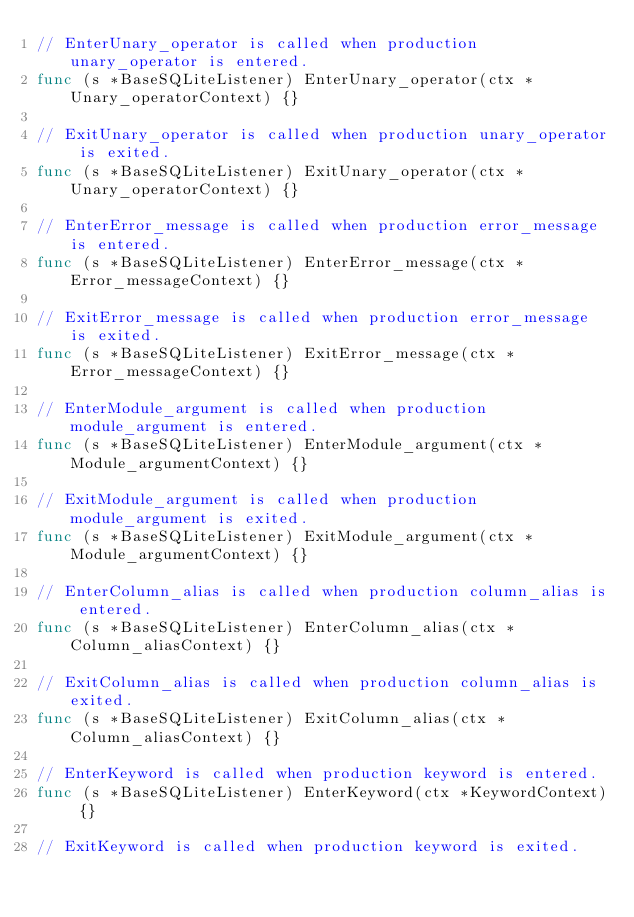<code> <loc_0><loc_0><loc_500><loc_500><_Go_>// EnterUnary_operator is called when production unary_operator is entered.
func (s *BaseSQLiteListener) EnterUnary_operator(ctx *Unary_operatorContext) {}

// ExitUnary_operator is called when production unary_operator is exited.
func (s *BaseSQLiteListener) ExitUnary_operator(ctx *Unary_operatorContext) {}

// EnterError_message is called when production error_message is entered.
func (s *BaseSQLiteListener) EnterError_message(ctx *Error_messageContext) {}

// ExitError_message is called when production error_message is exited.
func (s *BaseSQLiteListener) ExitError_message(ctx *Error_messageContext) {}

// EnterModule_argument is called when production module_argument is entered.
func (s *BaseSQLiteListener) EnterModule_argument(ctx *Module_argumentContext) {}

// ExitModule_argument is called when production module_argument is exited.
func (s *BaseSQLiteListener) ExitModule_argument(ctx *Module_argumentContext) {}

// EnterColumn_alias is called when production column_alias is entered.
func (s *BaseSQLiteListener) EnterColumn_alias(ctx *Column_aliasContext) {}

// ExitColumn_alias is called when production column_alias is exited.
func (s *BaseSQLiteListener) ExitColumn_alias(ctx *Column_aliasContext) {}

// EnterKeyword is called when production keyword is entered.
func (s *BaseSQLiteListener) EnterKeyword(ctx *KeywordContext) {}

// ExitKeyword is called when production keyword is exited.</code> 